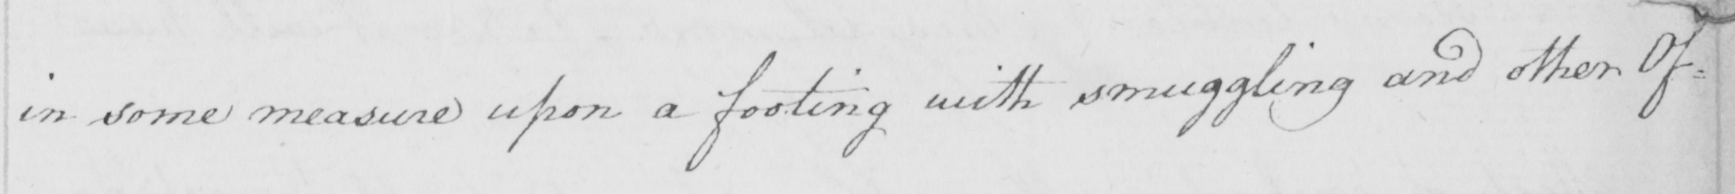Please transcribe the handwritten text in this image. in some measure upon a footing with smuggling and other Of- 